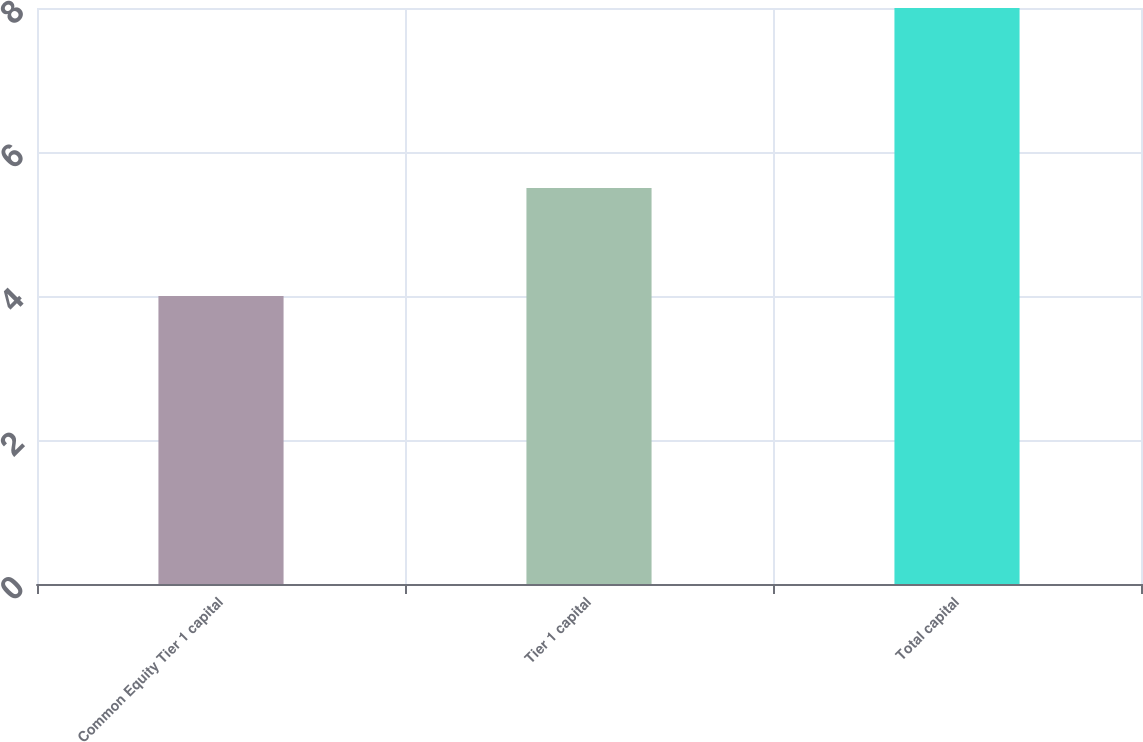Convert chart to OTSL. <chart><loc_0><loc_0><loc_500><loc_500><bar_chart><fcel>Common Equity Tier 1 capital<fcel>Tier 1 capital<fcel>Total capital<nl><fcel>4<fcel>5.5<fcel>8<nl></chart> 